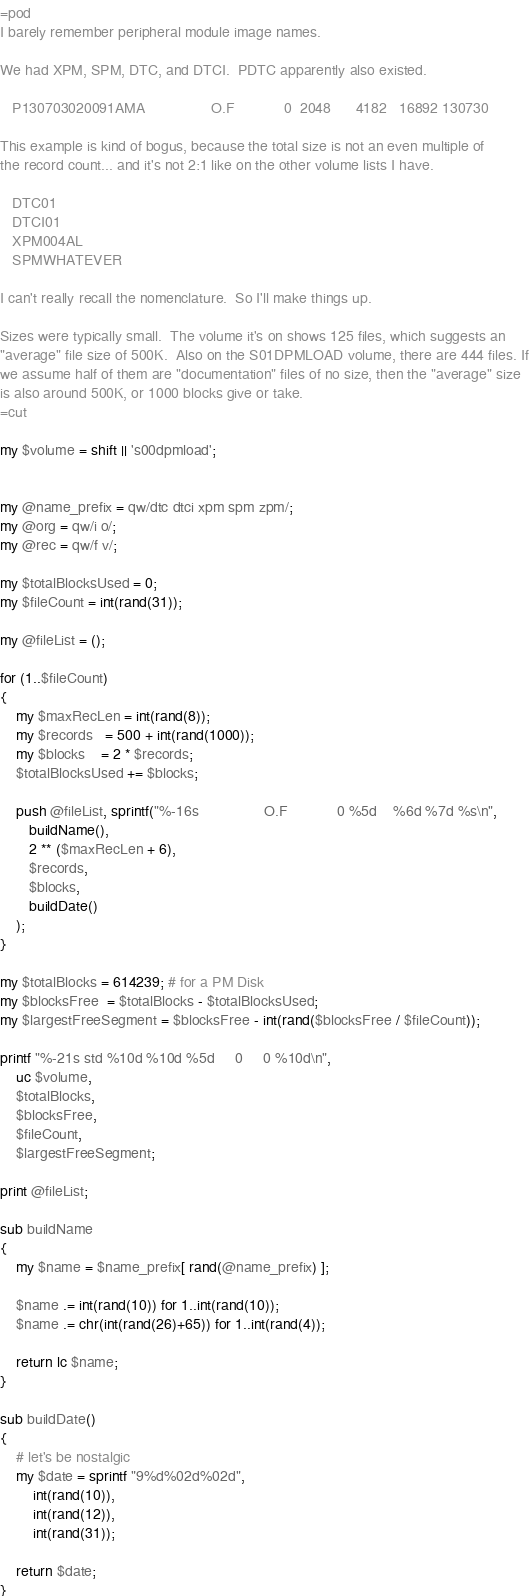Convert code to text. <code><loc_0><loc_0><loc_500><loc_500><_Perl_>=pod
I barely remember peripheral module image names.

We had XPM, SPM, DTC, and DTCI.  PDTC apparently also existed.

   P130703020091AMA                O.F            0  2048      4182   16892 130730

This example is kind of bogus, because the total size is not an even multiple of
the record count... and it's not 2:1 like on the other volume lists I have.

   DTC01
   DTCI01
   XPM004AL
   SPMWHATEVER

I can't really recall the nomenclature.  So I'll make things up.

Sizes were typically small.  The volume it's on shows 125 files, which suggests an 
"average" file size of 500K.  Also on the S01DPMLOAD volume, there are 444 files. If
we assume half of them are "documentation" files of no size, then the "average" size
is also around 500K, or 1000 blocks give or take.
=cut

my $volume = shift || 's00dpmload';


my @name_prefix = qw/dtc dtci xpm spm zpm/;
my @org = qw/i o/;
my @rec = qw/f v/;

my $totalBlocksUsed = 0;
my $fileCount = int(rand(31));

my @fileList = ();

for (1..$fileCount)
{
    my $maxRecLen = int(rand(8));   
    my $records   = 500 + int(rand(1000));
    my $blocks    = 2 * $records;
    $totalBlocksUsed += $blocks;

    push @fileList, sprintf("%-16s                O.F            0 %5d    %6d %7d %s\n",
       buildName(),
       2 ** ($maxRecLen + 6),
       $records,
       $blocks,
       buildDate()
    );
}

my $totalBlocks = 614239; # for a PM Disk
my $blocksFree  = $totalBlocks - $totalBlocksUsed;
my $largestFreeSegment = $blocksFree - int(rand($blocksFree / $fileCount));

printf "%-21s std %10d %10d %5d     0     0 %10d\n",
    uc $volume,
    $totalBlocks,
    $blocksFree,
    $fileCount,
    $largestFreeSegment;

print @fileList;

sub buildName
{
    my $name = $name_prefix[ rand(@name_prefix) ];

    $name .= int(rand(10)) for 1..int(rand(10));
    $name .= chr(int(rand(26)+65)) for 1..int(rand(4));

    return lc $name;
}

sub buildDate()
{
    # let's be nostalgic
    my $date = sprintf "9%d%02d%02d",
        int(rand(10)),
        int(rand(12)),
        int(rand(31));

    return $date;
}</code> 